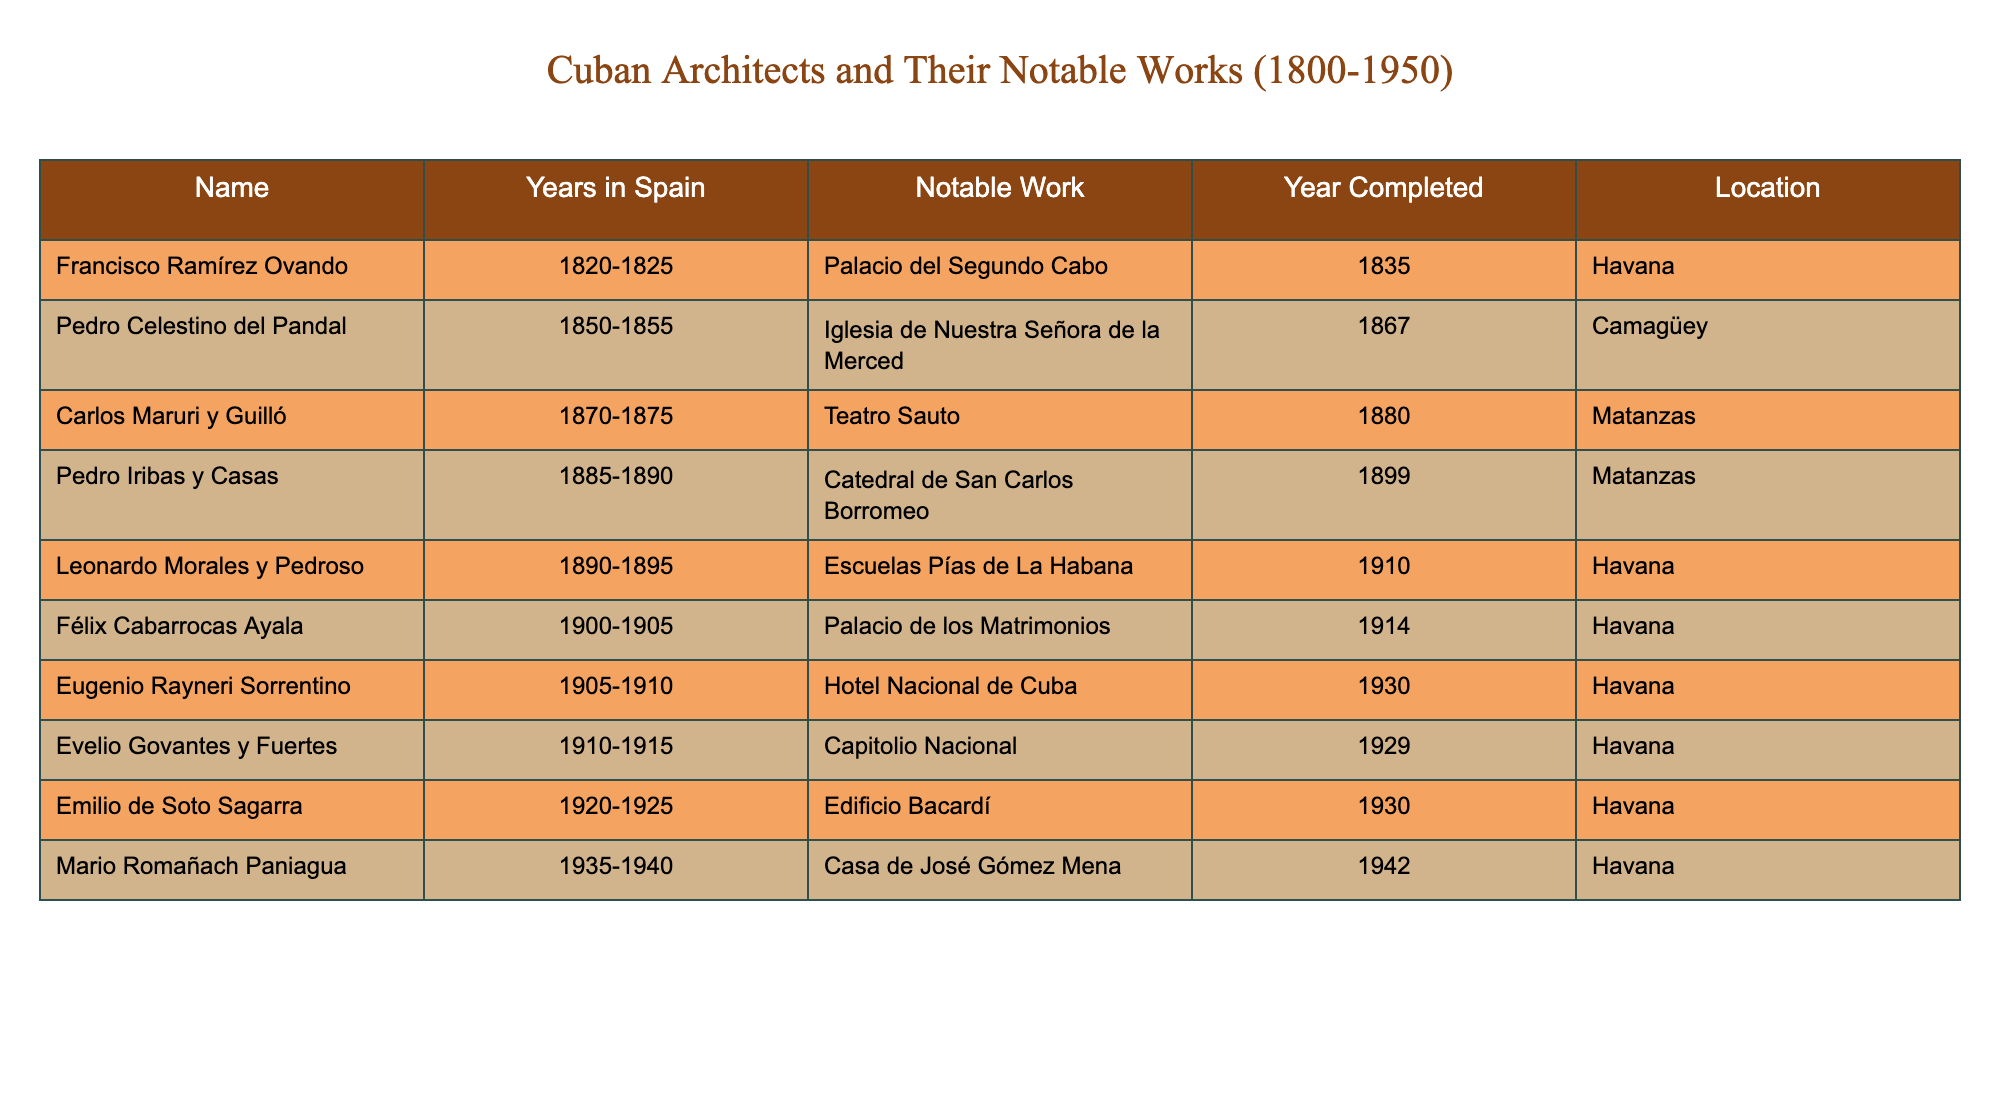What is the notable work of Francisco Ramírez Ovando? According to the table, Francisco Ramírez Ovando’s notable work is the Palacio del Segundo Cabo.
Answer: Palacio del Segundo Cabo Which architect completed their notable work in 1930? The table shows that both Eugenio Rayneri Sorrentino and Emilio de Soto Sagarra completed notable works in 1930, specifically the Hotel Nacional de Cuba and the Edificio Bacardí, respectively.
Answer: Eugenio Rayneri Sorrentino and Emilio de Soto Sagarra What is the location of the Catedral de San Carlos Borromeo? The table states that the Catedral de San Carlos Borromeo, designed by Pedro Iribas y Casas, is located in Matanzas.
Answer: Matanzas How many years did Carlos Maruri y Guilló study in Spain? Carlos Maruri y Guilló studied in Spain for 5 years, from 1870 to 1875.
Answer: 5 years Which architect is associated with the Capitolio Nacional? The table indicates Evelio Govantes y Fuertes is associated with the Capitolio Nacional as his notable work.
Answer: Evelio Govantes y Fuertes What is the average year of completion for the notable works listed in the table? To find the average, first sum the years of completion: 1835 + 1867 + 1880 + 1899 + 1910 + 1914 + 1930 + 1929 + 1930 + 1942 = 1936. Then divide by the number of architects (10), which results in 193.6. Rounding, the average year is approximately 1936.
Answer: 1936 Did any architect complete their work before 1900? Yes, the table shows that Francisco Ramírez Ovando, Pedro Celestino del Pandal, Carlos Maruri y Guilló, and Pedro Iribas y Casas all completed their notable works before 1900.
Answer: Yes Which location has the most architects listed in the table? Upon reviewing the table, Havana appears most frequently, with five architects completing their notable works there, specifically Ramírez Ovando, Morales y Pedroso, Cabarrocas Ayala, Rayneri Sorrentino, Govantes y Fuertes, and de Soto Sagarra.
Answer: Havana What notable work was completed last according to the table? The last notable work according to the completion year in the table is Casa de José Gómez Mena, completed in 1942 by Mario Romañach Paniagua.
Answer: Casa de José Gómez Mena Is there an architect who studied in Spain for less than 5 years? No, all listed architects in the table studied in Spain for at least 5 years, ranging from 5 to 10 years.
Answer: No 